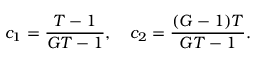<formula> <loc_0><loc_0><loc_500><loc_500>c _ { 1 } = \frac { T - 1 } { G T - 1 } , \quad c _ { 2 } = \frac { ( G - 1 ) T } { G T - 1 } .</formula> 